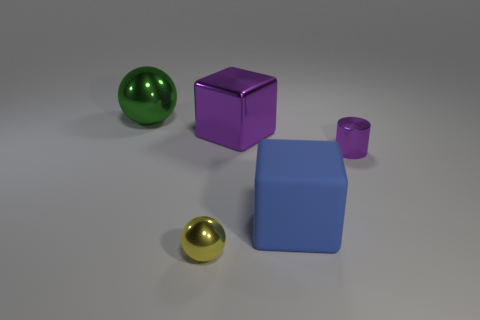Add 5 purple metal blocks. How many objects exist? 10 Subtract all cylinders. How many objects are left? 4 Subtract all large brown shiny spheres. Subtract all large blue blocks. How many objects are left? 4 Add 2 small yellow things. How many small yellow things are left? 3 Add 1 large green shiny cylinders. How many large green shiny cylinders exist? 1 Subtract 0 gray spheres. How many objects are left? 5 